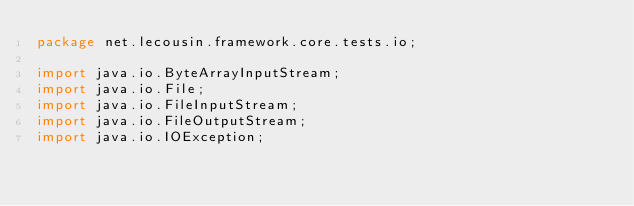<code> <loc_0><loc_0><loc_500><loc_500><_Java_>package net.lecousin.framework.core.tests.io;

import java.io.ByteArrayInputStream;
import java.io.File;
import java.io.FileInputStream;
import java.io.FileOutputStream;
import java.io.IOException;</code> 